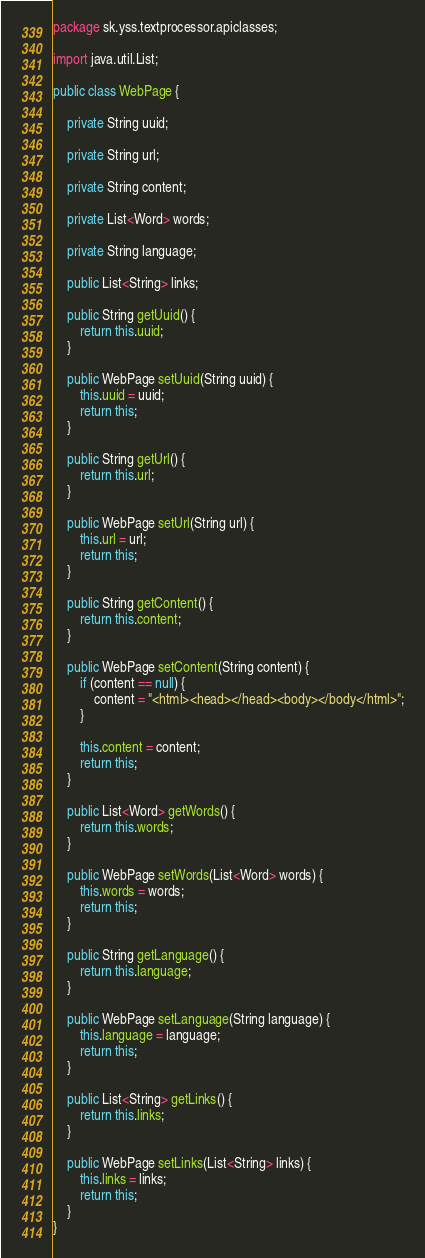<code> <loc_0><loc_0><loc_500><loc_500><_Java_>package sk.yss.textprocessor.apiclasses;

import java.util.List;

public class WebPage {

	private String uuid;

	private String url;

	private String content;

	private List<Word> words;

	private String language;

	public List<String> links;

	public String getUuid() {
		return this.uuid;
	}

	public WebPage setUuid(String uuid) {
		this.uuid = uuid;
		return this;
	}

	public String getUrl() {
		return this.url;
	}

	public WebPage setUrl(String url) {
		this.url = url;
		return this;
	}

	public String getContent() {
		return this.content;
	}

	public WebPage setContent(String content) {
		if (content == null) {
			content = "<html><head></head><body></body</html>";
		}

		this.content = content;
		return this;
	}

	public List<Word> getWords() {
		return this.words;
	}

	public WebPage setWords(List<Word> words) {
		this.words = words;
		return this;
	}

	public String getLanguage() {
		return this.language;
	}

	public WebPage setLanguage(String language) {
		this.language = language;
		return this;
	}

	public List<String> getLinks() {
		return this.links;
	}

	public WebPage setLinks(List<String> links) {
		this.links = links;
		return this;
	}
}
</code> 